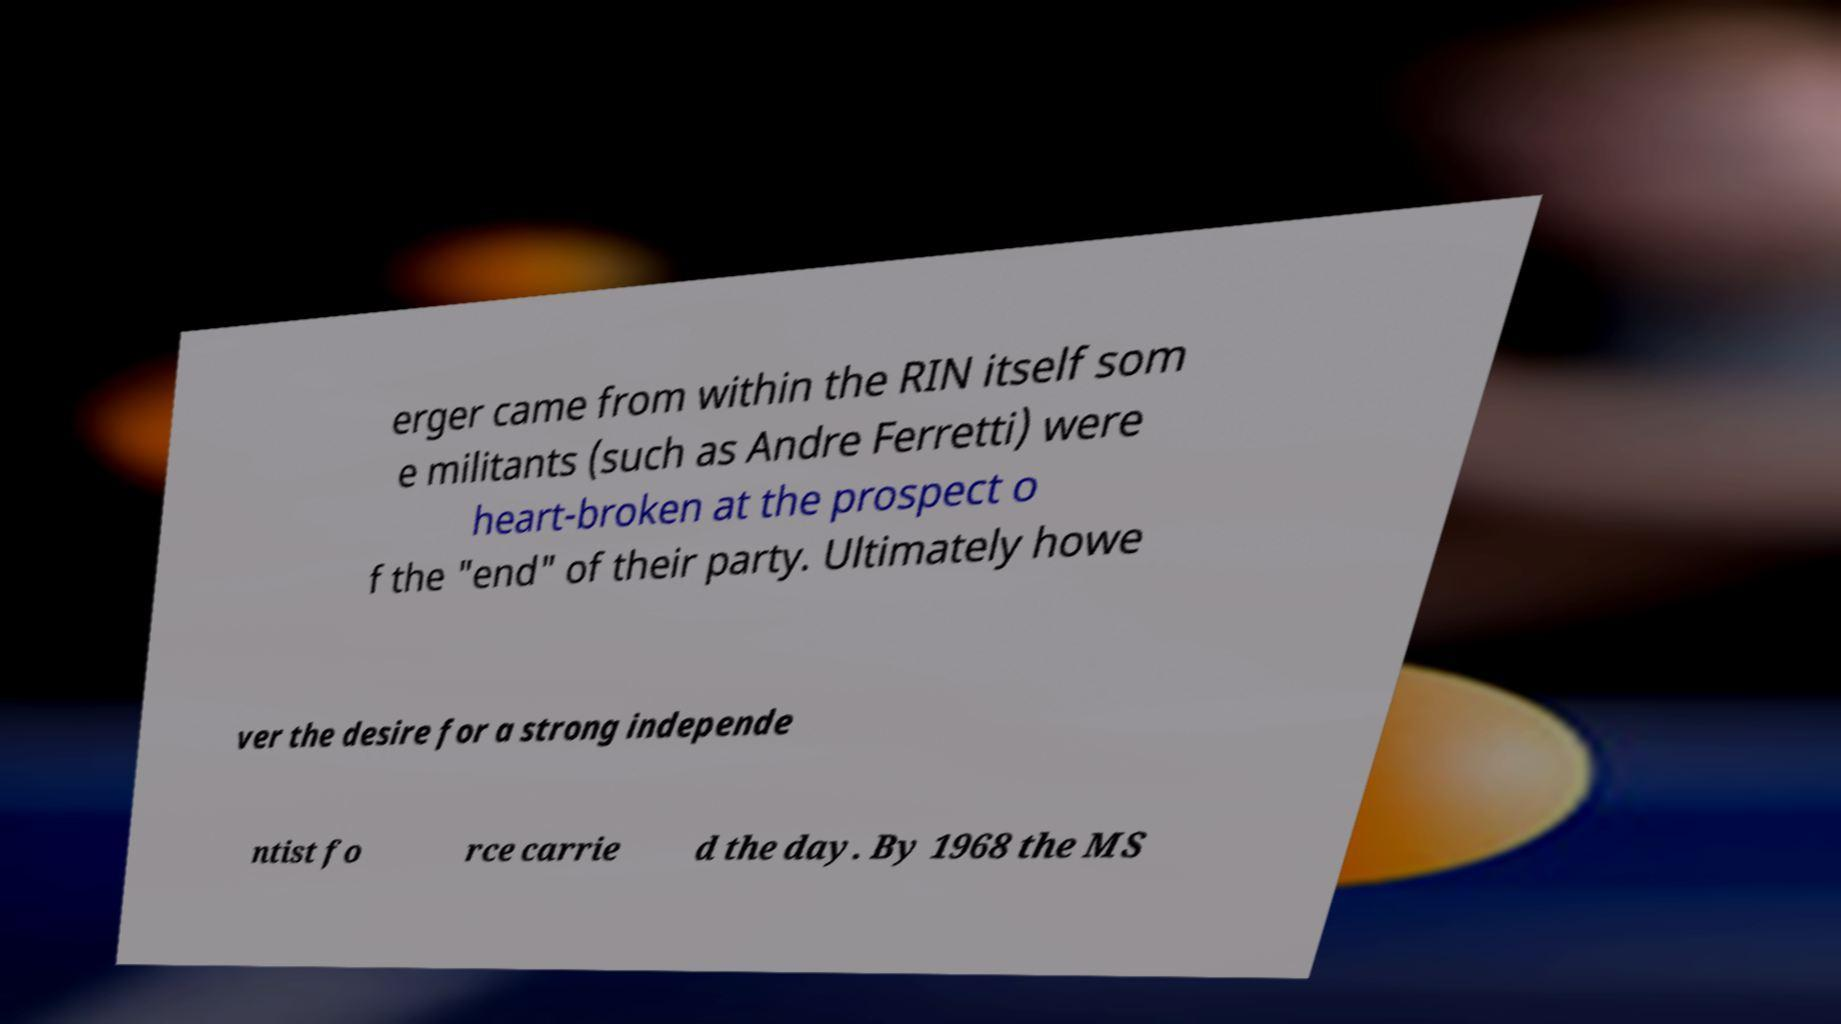For documentation purposes, I need the text within this image transcribed. Could you provide that? erger came from within the RIN itself som e militants (such as Andre Ferretti) were heart-broken at the prospect o f the "end" of their party. Ultimately howe ver the desire for a strong independe ntist fo rce carrie d the day. By 1968 the MS 